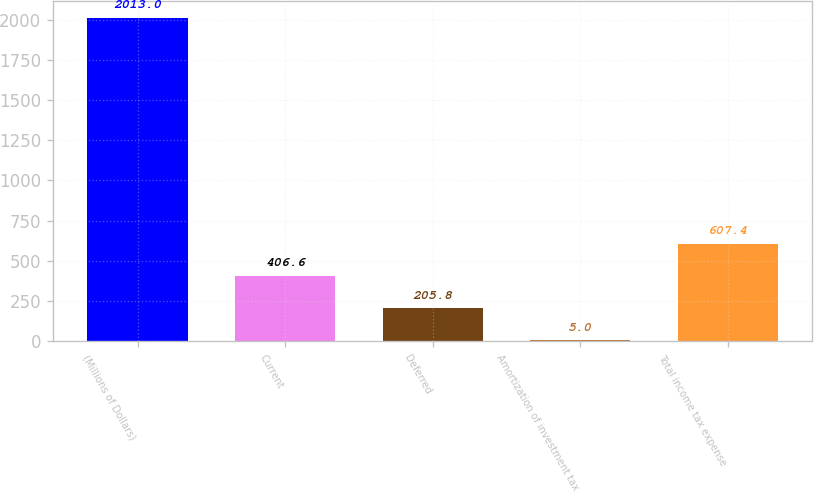Convert chart. <chart><loc_0><loc_0><loc_500><loc_500><bar_chart><fcel>(Millions of Dollars)<fcel>Current<fcel>Deferred<fcel>Amortization of investment tax<fcel>Total income tax expense<nl><fcel>2013<fcel>406.6<fcel>205.8<fcel>5<fcel>607.4<nl></chart> 